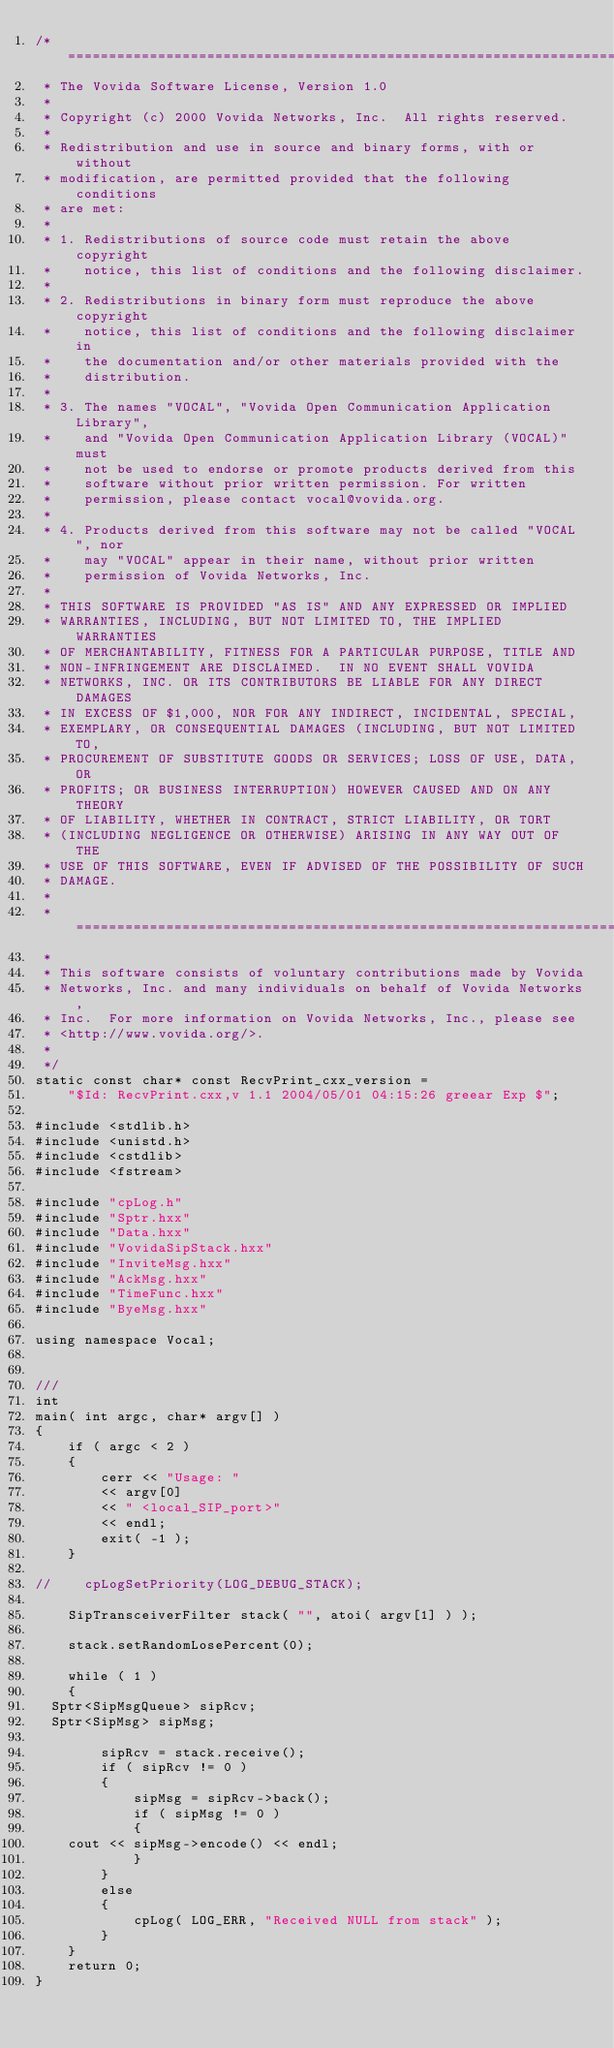<code> <loc_0><loc_0><loc_500><loc_500><_C++_>/* ====================================================================
 * The Vovida Software License, Version 1.0 
 * 
 * Copyright (c) 2000 Vovida Networks, Inc.  All rights reserved.
 * 
 * Redistribution and use in source and binary forms, with or without
 * modification, are permitted provided that the following conditions
 * are met:
 * 
 * 1. Redistributions of source code must retain the above copyright
 *    notice, this list of conditions and the following disclaimer.
 * 
 * 2. Redistributions in binary form must reproduce the above copyright
 *    notice, this list of conditions and the following disclaimer in
 *    the documentation and/or other materials provided with the
 *    distribution.
 * 
 * 3. The names "VOCAL", "Vovida Open Communication Application Library",
 *    and "Vovida Open Communication Application Library (VOCAL)" must
 *    not be used to endorse or promote products derived from this
 *    software without prior written permission. For written
 *    permission, please contact vocal@vovida.org.
 *
 * 4. Products derived from this software may not be called "VOCAL", nor
 *    may "VOCAL" appear in their name, without prior written
 *    permission of Vovida Networks, Inc.
 * 
 * THIS SOFTWARE IS PROVIDED "AS IS" AND ANY EXPRESSED OR IMPLIED
 * WARRANTIES, INCLUDING, BUT NOT LIMITED TO, THE IMPLIED WARRANTIES
 * OF MERCHANTABILITY, FITNESS FOR A PARTICULAR PURPOSE, TITLE AND
 * NON-INFRINGEMENT ARE DISCLAIMED.  IN NO EVENT SHALL VOVIDA
 * NETWORKS, INC. OR ITS CONTRIBUTORS BE LIABLE FOR ANY DIRECT DAMAGES
 * IN EXCESS OF $1,000, NOR FOR ANY INDIRECT, INCIDENTAL, SPECIAL,
 * EXEMPLARY, OR CONSEQUENTIAL DAMAGES (INCLUDING, BUT NOT LIMITED TO,
 * PROCUREMENT OF SUBSTITUTE GOODS OR SERVICES; LOSS OF USE, DATA, OR
 * PROFITS; OR BUSINESS INTERRUPTION) HOWEVER CAUSED AND ON ANY THEORY
 * OF LIABILITY, WHETHER IN CONTRACT, STRICT LIABILITY, OR TORT
 * (INCLUDING NEGLIGENCE OR OTHERWISE) ARISING IN ANY WAY OUT OF THE
 * USE OF THIS SOFTWARE, EVEN IF ADVISED OF THE POSSIBILITY OF SUCH
 * DAMAGE.
 * 
 * ====================================================================
 * 
 * This software consists of voluntary contributions made by Vovida
 * Networks, Inc. and many individuals on behalf of Vovida Networks,
 * Inc.  For more information on Vovida Networks, Inc., please see
 * <http://www.vovida.org/>.
 *
 */
static const char* const RecvPrint_cxx_version =
    "$Id: RecvPrint.cxx,v 1.1 2004/05/01 04:15:26 greear Exp $";

#include <stdlib.h>
#include <unistd.h>
#include <cstdlib>
#include <fstream>

#include "cpLog.h"
#include "Sptr.hxx"
#include "Data.hxx"
#include "VovidaSipStack.hxx"
#include "InviteMsg.hxx"
#include "AckMsg.hxx"
#include "TimeFunc.hxx"
#include "ByeMsg.hxx"

using namespace Vocal;


///
int
main( int argc, char* argv[] )
{
    if ( argc < 2 )
    {
        cerr << "Usage: "
        << argv[0]
        << " <local_SIP_port>"
        << endl;
        exit( -1 );
    }

//    cpLogSetPriority(LOG_DEBUG_STACK);

    SipTransceiverFilter stack( "", atoi( argv[1] ) );

    stack.setRandomLosePercent(0);

    while ( 1 )
    {
	Sptr<SipMsgQueue> sipRcv;
	Sptr<SipMsg> sipMsg;

        sipRcv = stack.receive();
        if ( sipRcv != 0 )
        {
            sipMsg = sipRcv->back();
            if ( sipMsg != 0 )
            {
		cout << sipMsg->encode() << endl;
            }
        }
        else
        {
            cpLog( LOG_ERR, "Received NULL from stack" );
        }
    }
    return 0;
}
</code> 